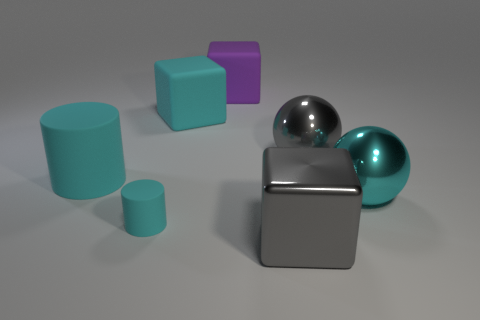What number of big objects are purple cubes or red metal cubes?
Your answer should be very brief. 1. There is a rubber object that is behind the big gray ball and to the left of the big purple block; what is its color?
Your answer should be compact. Cyan. Is there a green metallic thing that has the same shape as the large purple rubber thing?
Offer a very short reply. No. What material is the large cyan sphere?
Give a very brief answer. Metal. There is a large cyan metal sphere; are there any large shiny things in front of it?
Your answer should be very brief. Yes. Is the shape of the large purple object the same as the tiny matte thing?
Offer a very short reply. No. What number of other things are the same size as the cyan metallic thing?
Ensure brevity in your answer.  5. How many things are spheres that are left of the big cyan metallic thing or gray balls?
Provide a short and direct response. 1. What color is the tiny rubber cylinder?
Keep it short and to the point. Cyan. There is a cube on the right side of the large purple cube; what material is it?
Make the answer very short. Metal. 